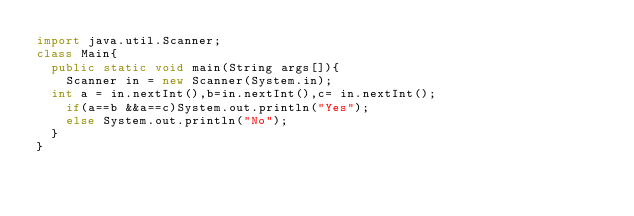<code> <loc_0><loc_0><loc_500><loc_500><_Java_>import java.util.Scanner;
class Main{
  public static void main(String args[]){
    Scanner in = new Scanner(System.in);
  int a = in.nextInt(),b=in.nextInt(),c= in.nextInt();
    if(a==b &&a==c)System.out.println("Yes");
    else System.out.println("No");
  }
}</code> 